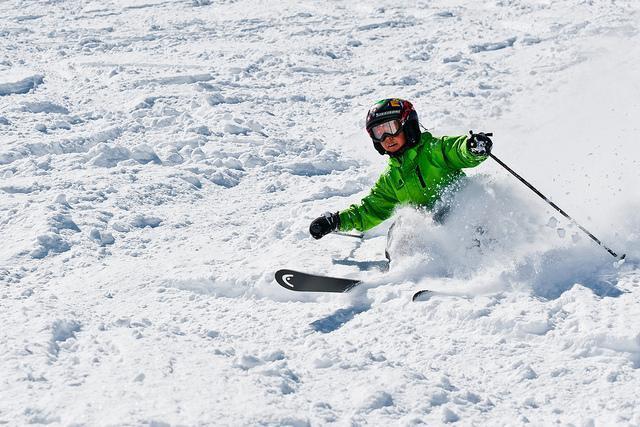How many ski poles are there?
Give a very brief answer. 2. How many cares are to the left of the bike rider?
Give a very brief answer. 0. 